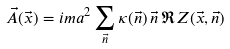<formula> <loc_0><loc_0><loc_500><loc_500>\vec { A } ( \vec { x } ) = i m a ^ { 2 } \sum _ { \vec { n } } \kappa ( \vec { n } ) \, \vec { n } \, \Re Z ( \vec { x } , \vec { n } )</formula> 